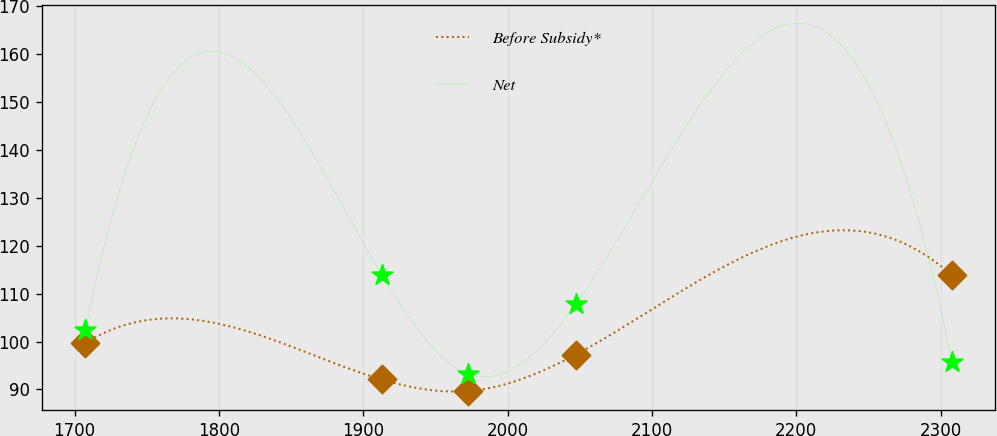<chart> <loc_0><loc_0><loc_500><loc_500><line_chart><ecel><fcel>Before Subsidy*<fcel>Net<nl><fcel>1707.38<fcel>99.69<fcel>102.32<nl><fcel>1912.72<fcel>92.08<fcel>113.95<nl><fcel>1972.77<fcel>89.67<fcel>93.21<nl><fcel>2047.35<fcel>97.28<fcel>107.82<nl><fcel>2307.84<fcel>113.8<fcel>95.72<nl></chart> 